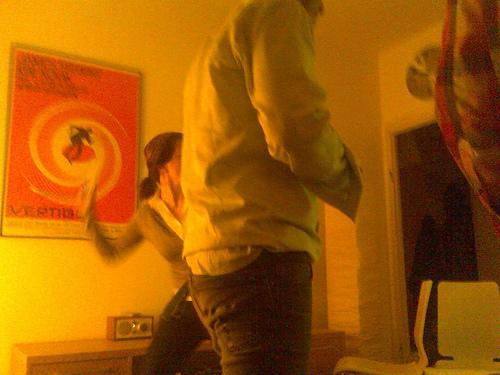What is the women about to do?

Choices:
A) throw something
B) high five
C) play game
D) hit someone play game 